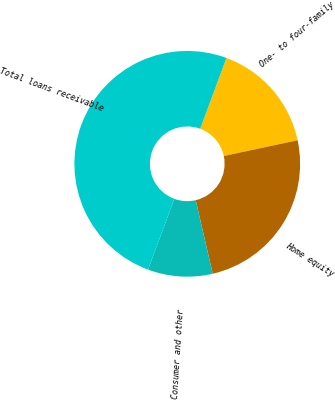<chart> <loc_0><loc_0><loc_500><loc_500><pie_chart><fcel>One- to four-family<fcel>Home equity<fcel>Consumer and other<fcel>Total loans receivable<nl><fcel>16.01%<fcel>24.72%<fcel>9.27%<fcel>50.0%<nl></chart> 